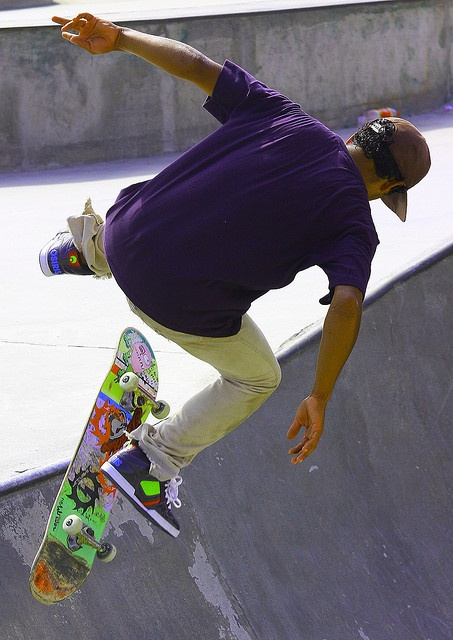Describe the objects in this image and their specific colors. I can see people in gray, black, olive, and navy tones and skateboard in gray, black, darkgray, and green tones in this image. 